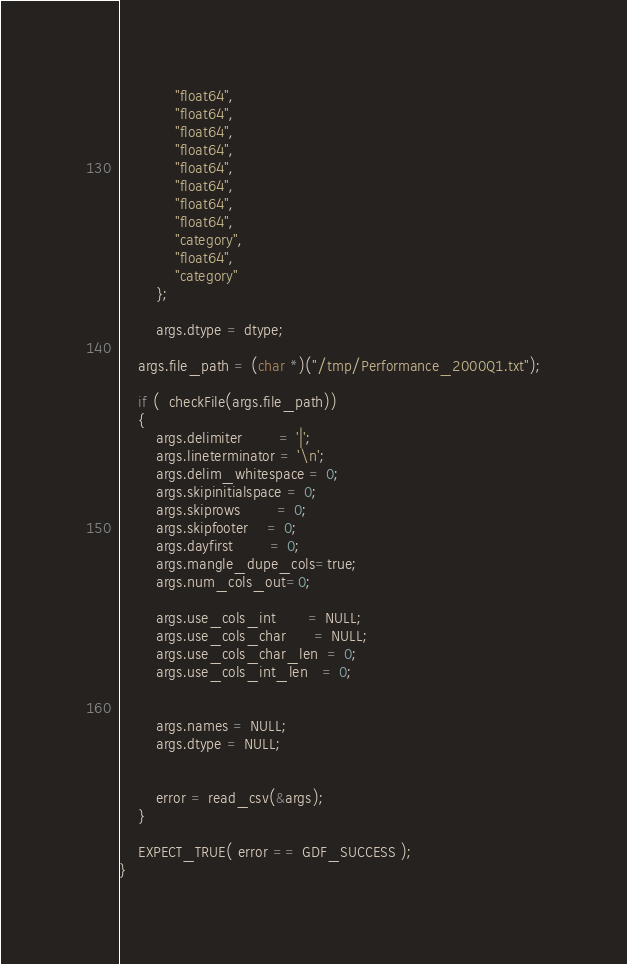Convert code to text. <code><loc_0><loc_0><loc_500><loc_500><_Cuda_>    		"float64",
    		"float64",
    		"float64",
    		"float64",
    		"float64",
    		"float64",
    		"float64",
    		"float64",
    		"category",
    		"float64",
    		"category"
        };

        args.dtype = dtype;

    args.file_path = (char *)("/tmp/Performance_2000Q1.txt");

	if (  checkFile(args.file_path))
	{
		args.delimiter 		= '|';
		args.lineterminator = '\n';
		args.delim_whitespace = 0;
		args.skipinitialspace = 0;
		args.skiprows 		= 0;
		args.skipfooter 	= 0;
		args.dayfirst 		= 0;
        args.mangle_dupe_cols=true;
        args.num_cols_out=0;

        args.use_cols_int       = NULL;
        args.use_cols_char      = NULL;
        args.use_cols_char_len  = 0;
        args.use_cols_int_len   = 0;


        args.names = NULL;
        args.dtype = NULL;


		error = read_csv(&args);
	}

	EXPECT_TRUE( error == GDF_SUCCESS );
}



</code> 